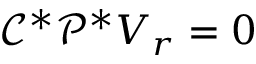<formula> <loc_0><loc_0><loc_500><loc_500>\mathcal { C } ^ { * } \mathcal { P } ^ { * } V _ { r } = 0</formula> 